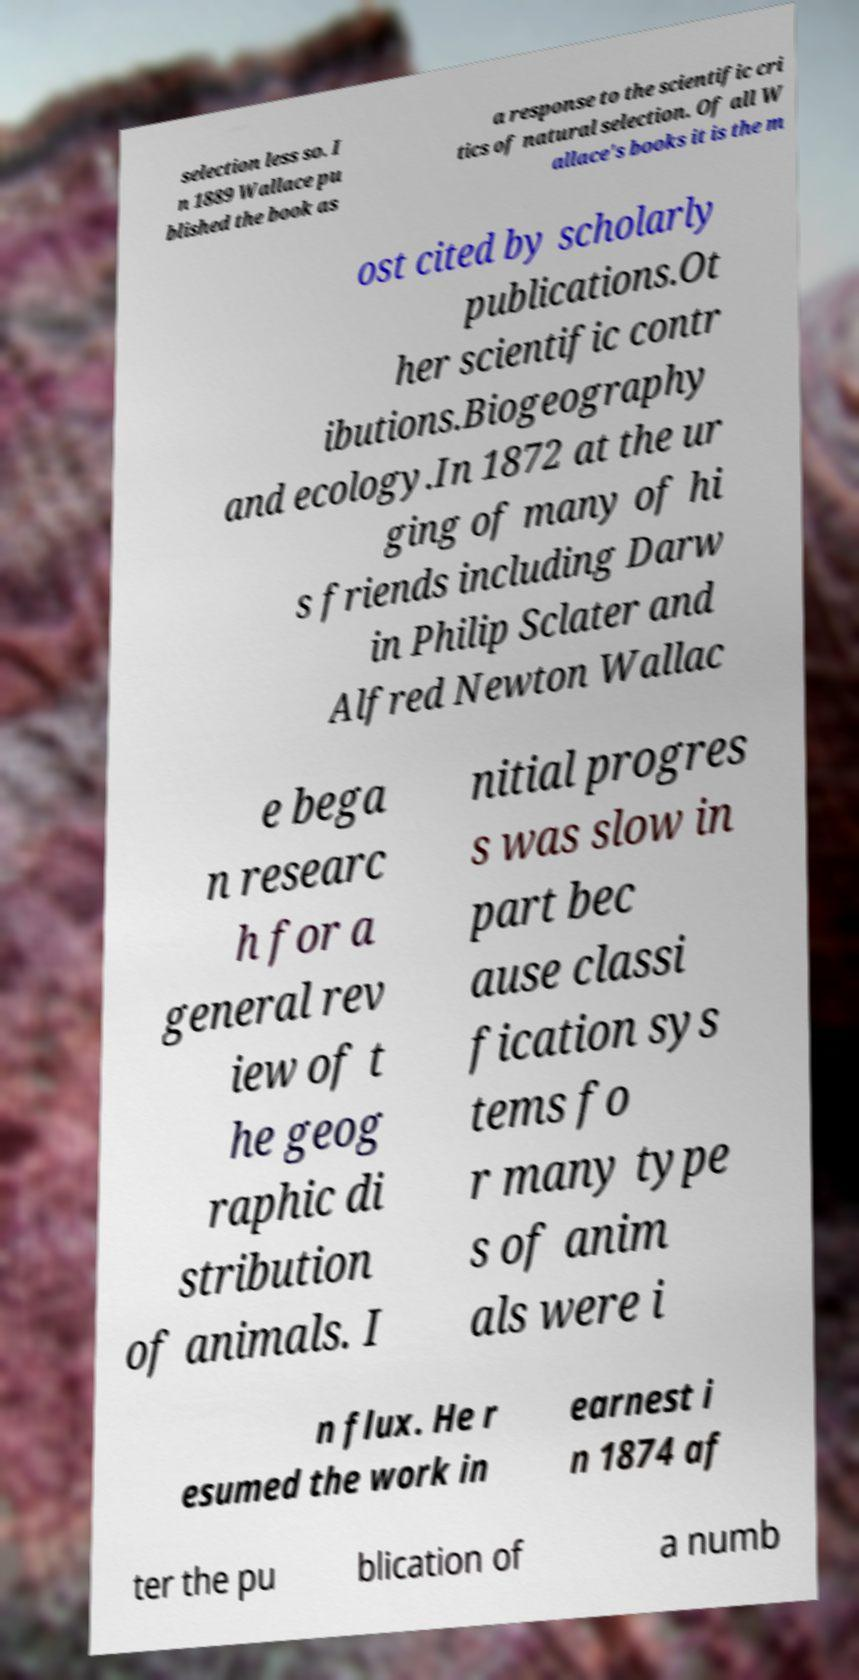Can you read and provide the text displayed in the image?This photo seems to have some interesting text. Can you extract and type it out for me? selection less so. I n 1889 Wallace pu blished the book as a response to the scientific cri tics of natural selection. Of all W allace's books it is the m ost cited by scholarly publications.Ot her scientific contr ibutions.Biogeography and ecology.In 1872 at the ur ging of many of hi s friends including Darw in Philip Sclater and Alfred Newton Wallac e bega n researc h for a general rev iew of t he geog raphic di stribution of animals. I nitial progres s was slow in part bec ause classi fication sys tems fo r many type s of anim als were i n flux. He r esumed the work in earnest i n 1874 af ter the pu blication of a numb 